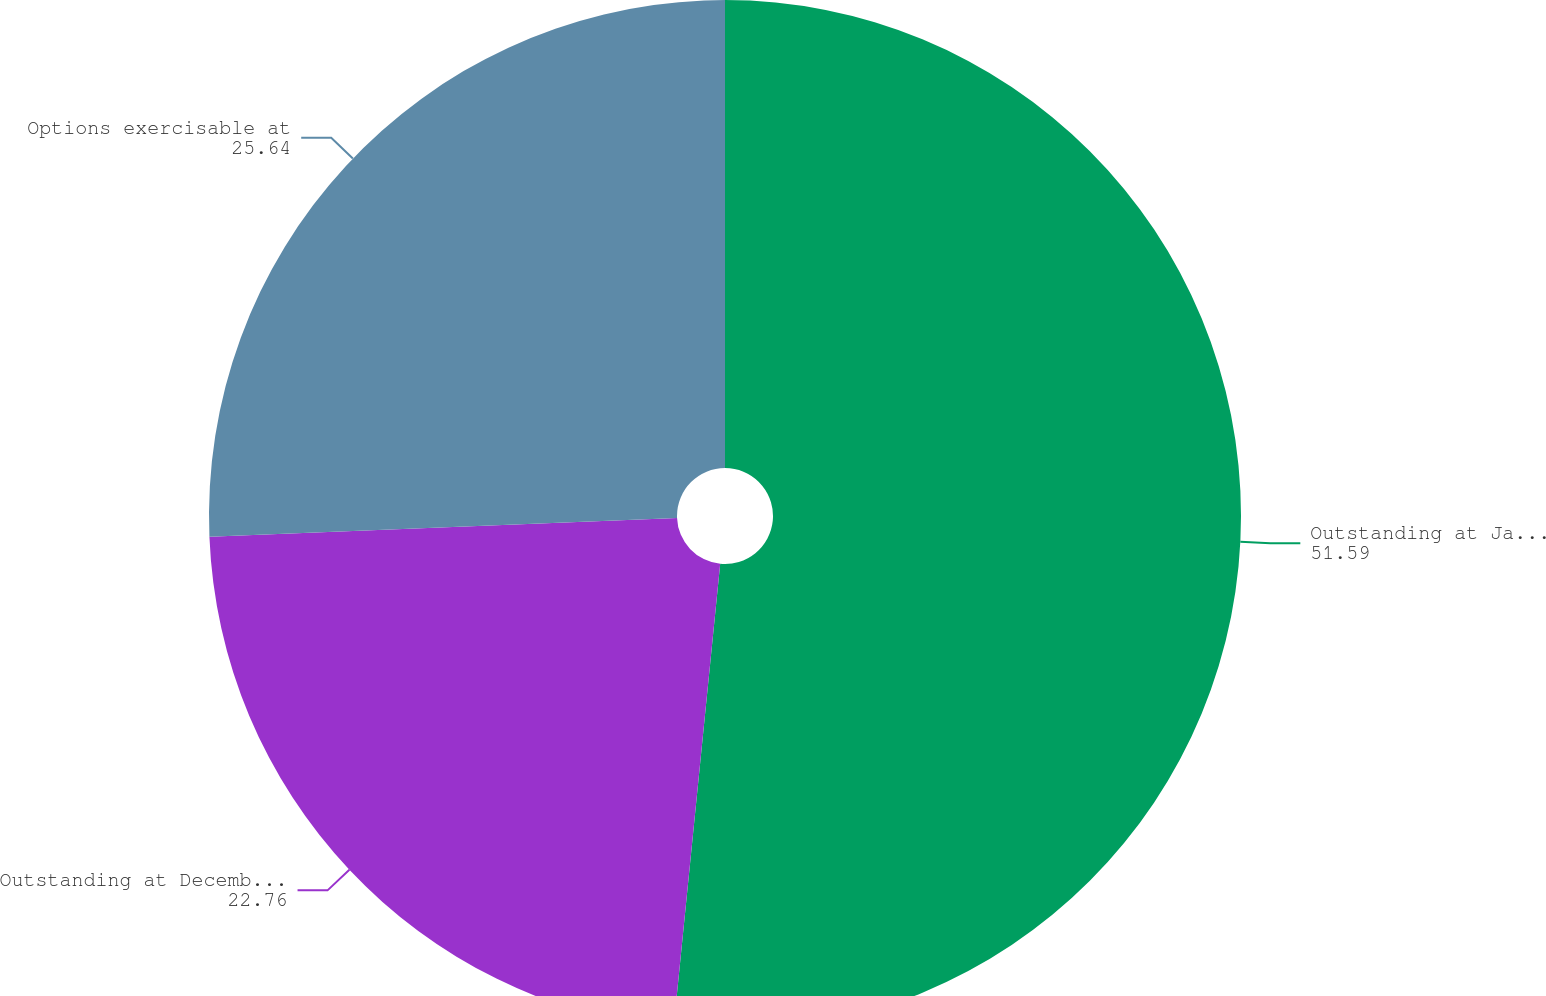Convert chart. <chart><loc_0><loc_0><loc_500><loc_500><pie_chart><fcel>Outstanding at January 1 2013<fcel>Outstanding at December 31<fcel>Options exercisable at<nl><fcel>51.59%<fcel>22.76%<fcel>25.64%<nl></chart> 